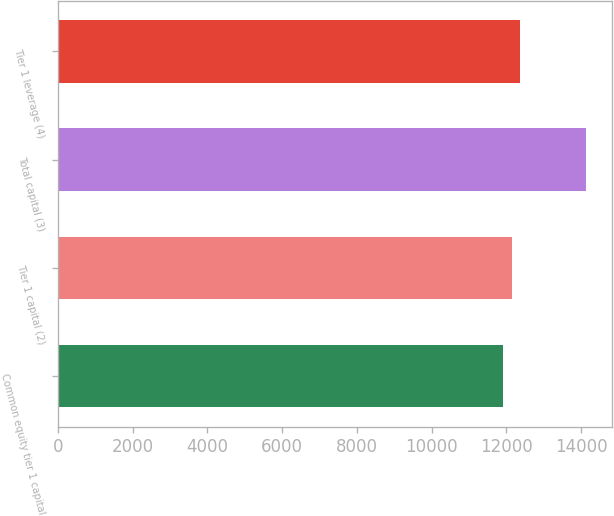<chart> <loc_0><loc_0><loc_500><loc_500><bar_chart><fcel>Common equity tier 1 capital<fcel>Tier 1 capital (2)<fcel>Total capital (3)<fcel>Tier 1 leverage (4)<nl><fcel>11917<fcel>12138<fcel>14127<fcel>12359<nl></chart> 